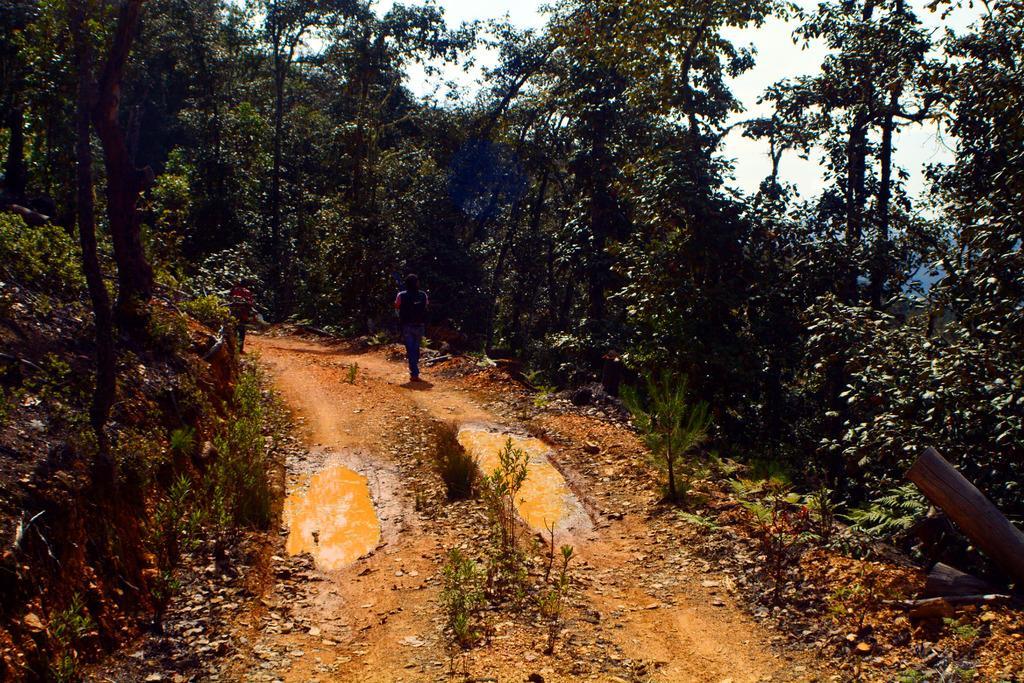Describe this image in one or two sentences. In this image there is ground, there is water on the ground, there are plants, there is a person walking, there are trees, there is a sky. 